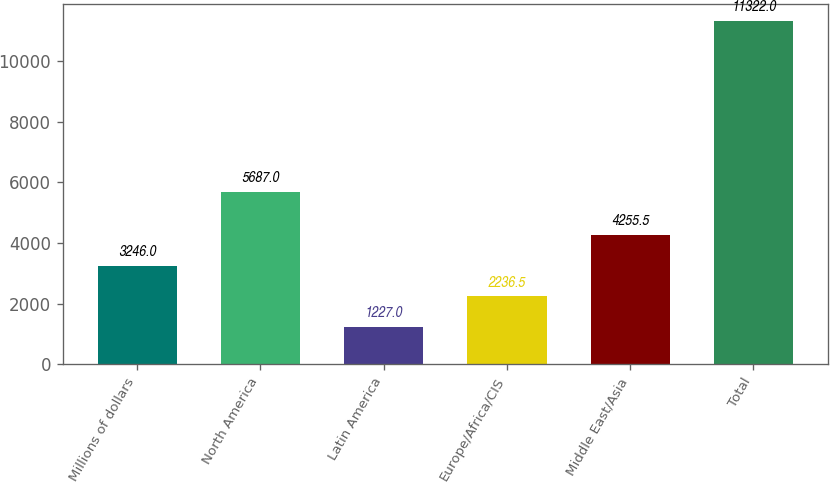<chart> <loc_0><loc_0><loc_500><loc_500><bar_chart><fcel>Millions of dollars<fcel>North America<fcel>Latin America<fcel>Europe/Africa/CIS<fcel>Middle East/Asia<fcel>Total<nl><fcel>3246<fcel>5687<fcel>1227<fcel>2236.5<fcel>4255.5<fcel>11322<nl></chart> 